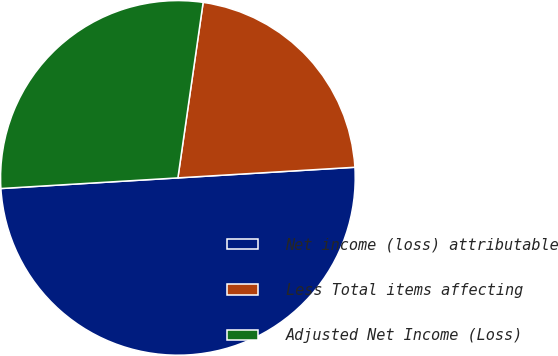Convert chart to OTSL. <chart><loc_0><loc_0><loc_500><loc_500><pie_chart><fcel>Net income (loss) attributable<fcel>Less Total items affecting<fcel>Adjusted Net Income (Loss)<nl><fcel>50.0%<fcel>21.77%<fcel>28.23%<nl></chart> 